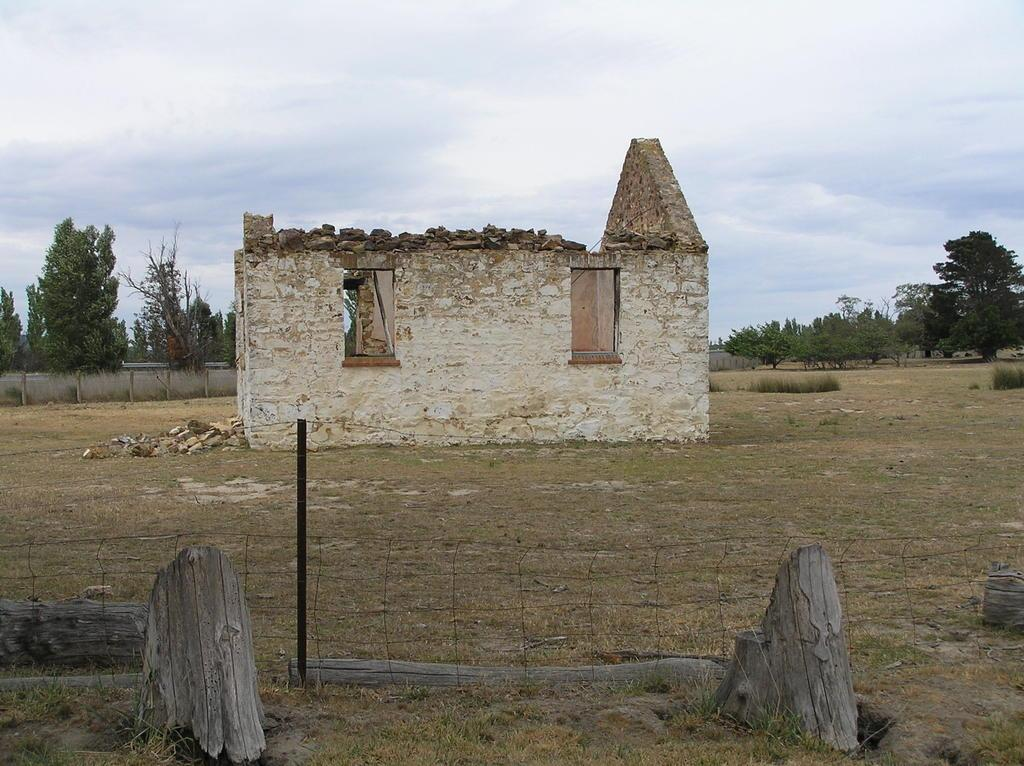What is located in front of the image? There is fencing in front of the image. What type of vegetation can be seen in the image? There is grass visible in the image. What structure is in the middle of the image? There is a house in the middle of the image. What can be seen in the background of the image? There is a wall, multiple trees, and the sky visible in the background of the image. How many snails can be seen climbing the wall in the image? There are no snails visible in the image; it only features fencing, grass, a house, a wall, trees, and the sky. What invention is being used by the trees in the background of the image? There is no invention present in the image; it only features trees in the background. 